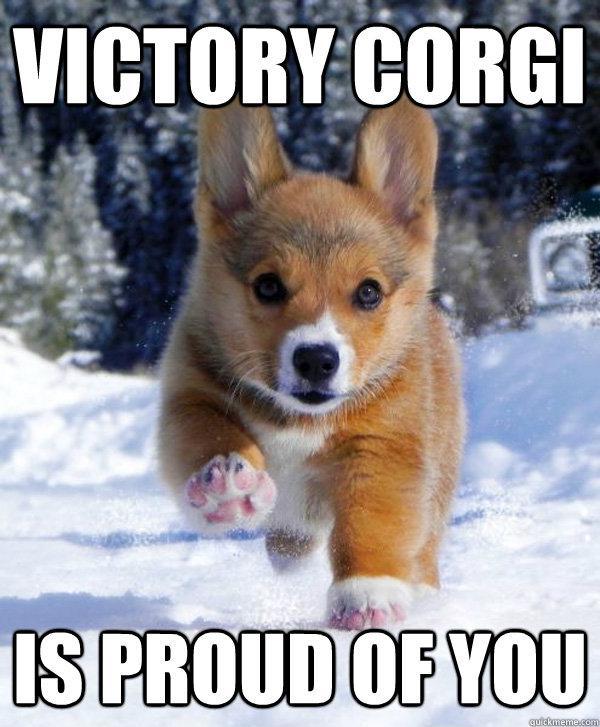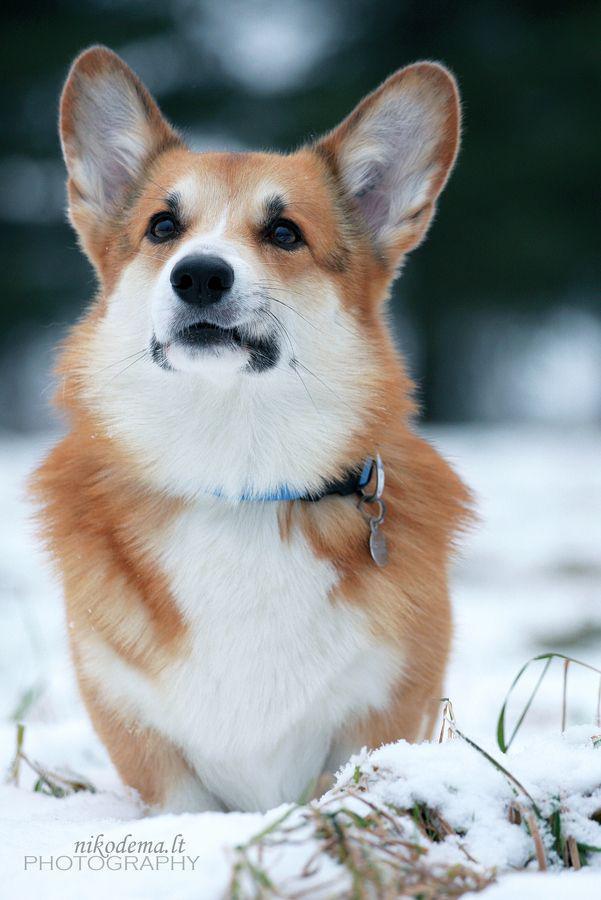The first image is the image on the left, the second image is the image on the right. Examine the images to the left and right. Is the description "There is 1 or more corgi's showing it's tongue." accurate? Answer yes or no. No. 